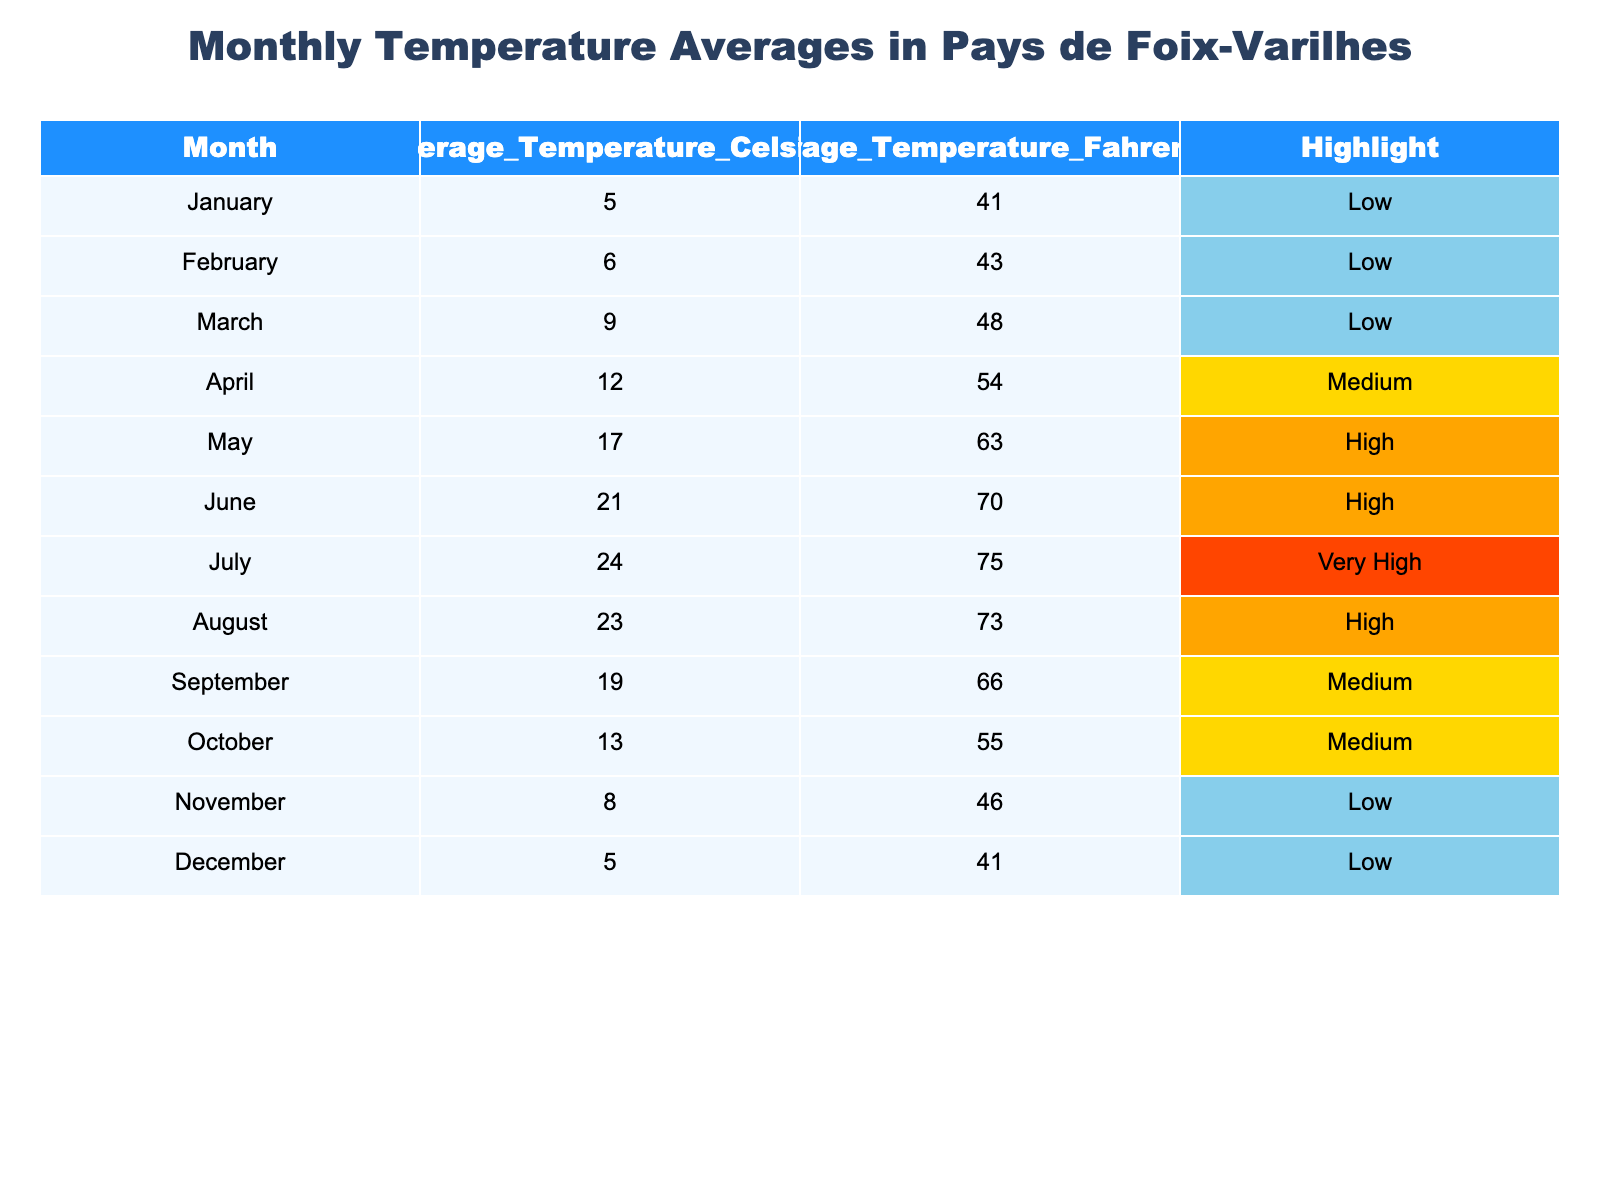What is the average temperature in July? The table shows the average temperature for July as 24 degrees Celsius.
Answer: 24 Which month has the lowest average temperature? By examining the table, January and December both have the lowest average temperature at 5 degrees Celsius.
Answer: January, December How many months have an average temperature above 20 degrees Celsius? From the table, the months with temperatures above 20 degrees Celsius are June (21), July (24), and August (23). That is three months in total.
Answer: 3 What is the average temperature in the months categorized as "High"? The months categorized as "High" are May (17), June (21), and August (23). The average is calculated as (17 + 21 + 23) / 3 = 61 / 3 = 20.33 degrees Celsius.
Answer: 20.33 Is the average temperature in October higher than in April? The table shows that October has an average temperature of 13 degrees Celsius while April has 12 degrees Celsius. Thus, October's temperature is higher.
Answer: Yes Which month has the highest average temperature and what is that temperature? According to the table, July has the highest average temperature at 24 degrees Celsius.
Answer: 24 in July If you lower July's average temperature by 5 degrees, what would it be? The original average temperature for July is 24 degrees Celsius. Subtracting 5 gives us 19 degrees Celsius.
Answer: 19 Are there more months labeled as "Low" or "High"? The months labeled as "Low" are January, February, March, November, and December (5 months). The "High" months are May, June, and August (3 months). Therefore, there are more "Low" months.
Answer: More "Low" months What is the range of average temperatures across the year? The highest average temperature is in July at 24 degrees Celsius and the lowest is in January and December at 5 degrees Celsius. Hence, the range is 24 - 5 = 19 degrees Celsius.
Answer: 19 Which months have an average temperature at or above the "Medium" level? The months with averages at or above "Medium" (12 to 19 degrees Celsius) include April (12), September (19), and October (13). Hence, there are four months in total: April, September, October, and May.
Answer: 4 